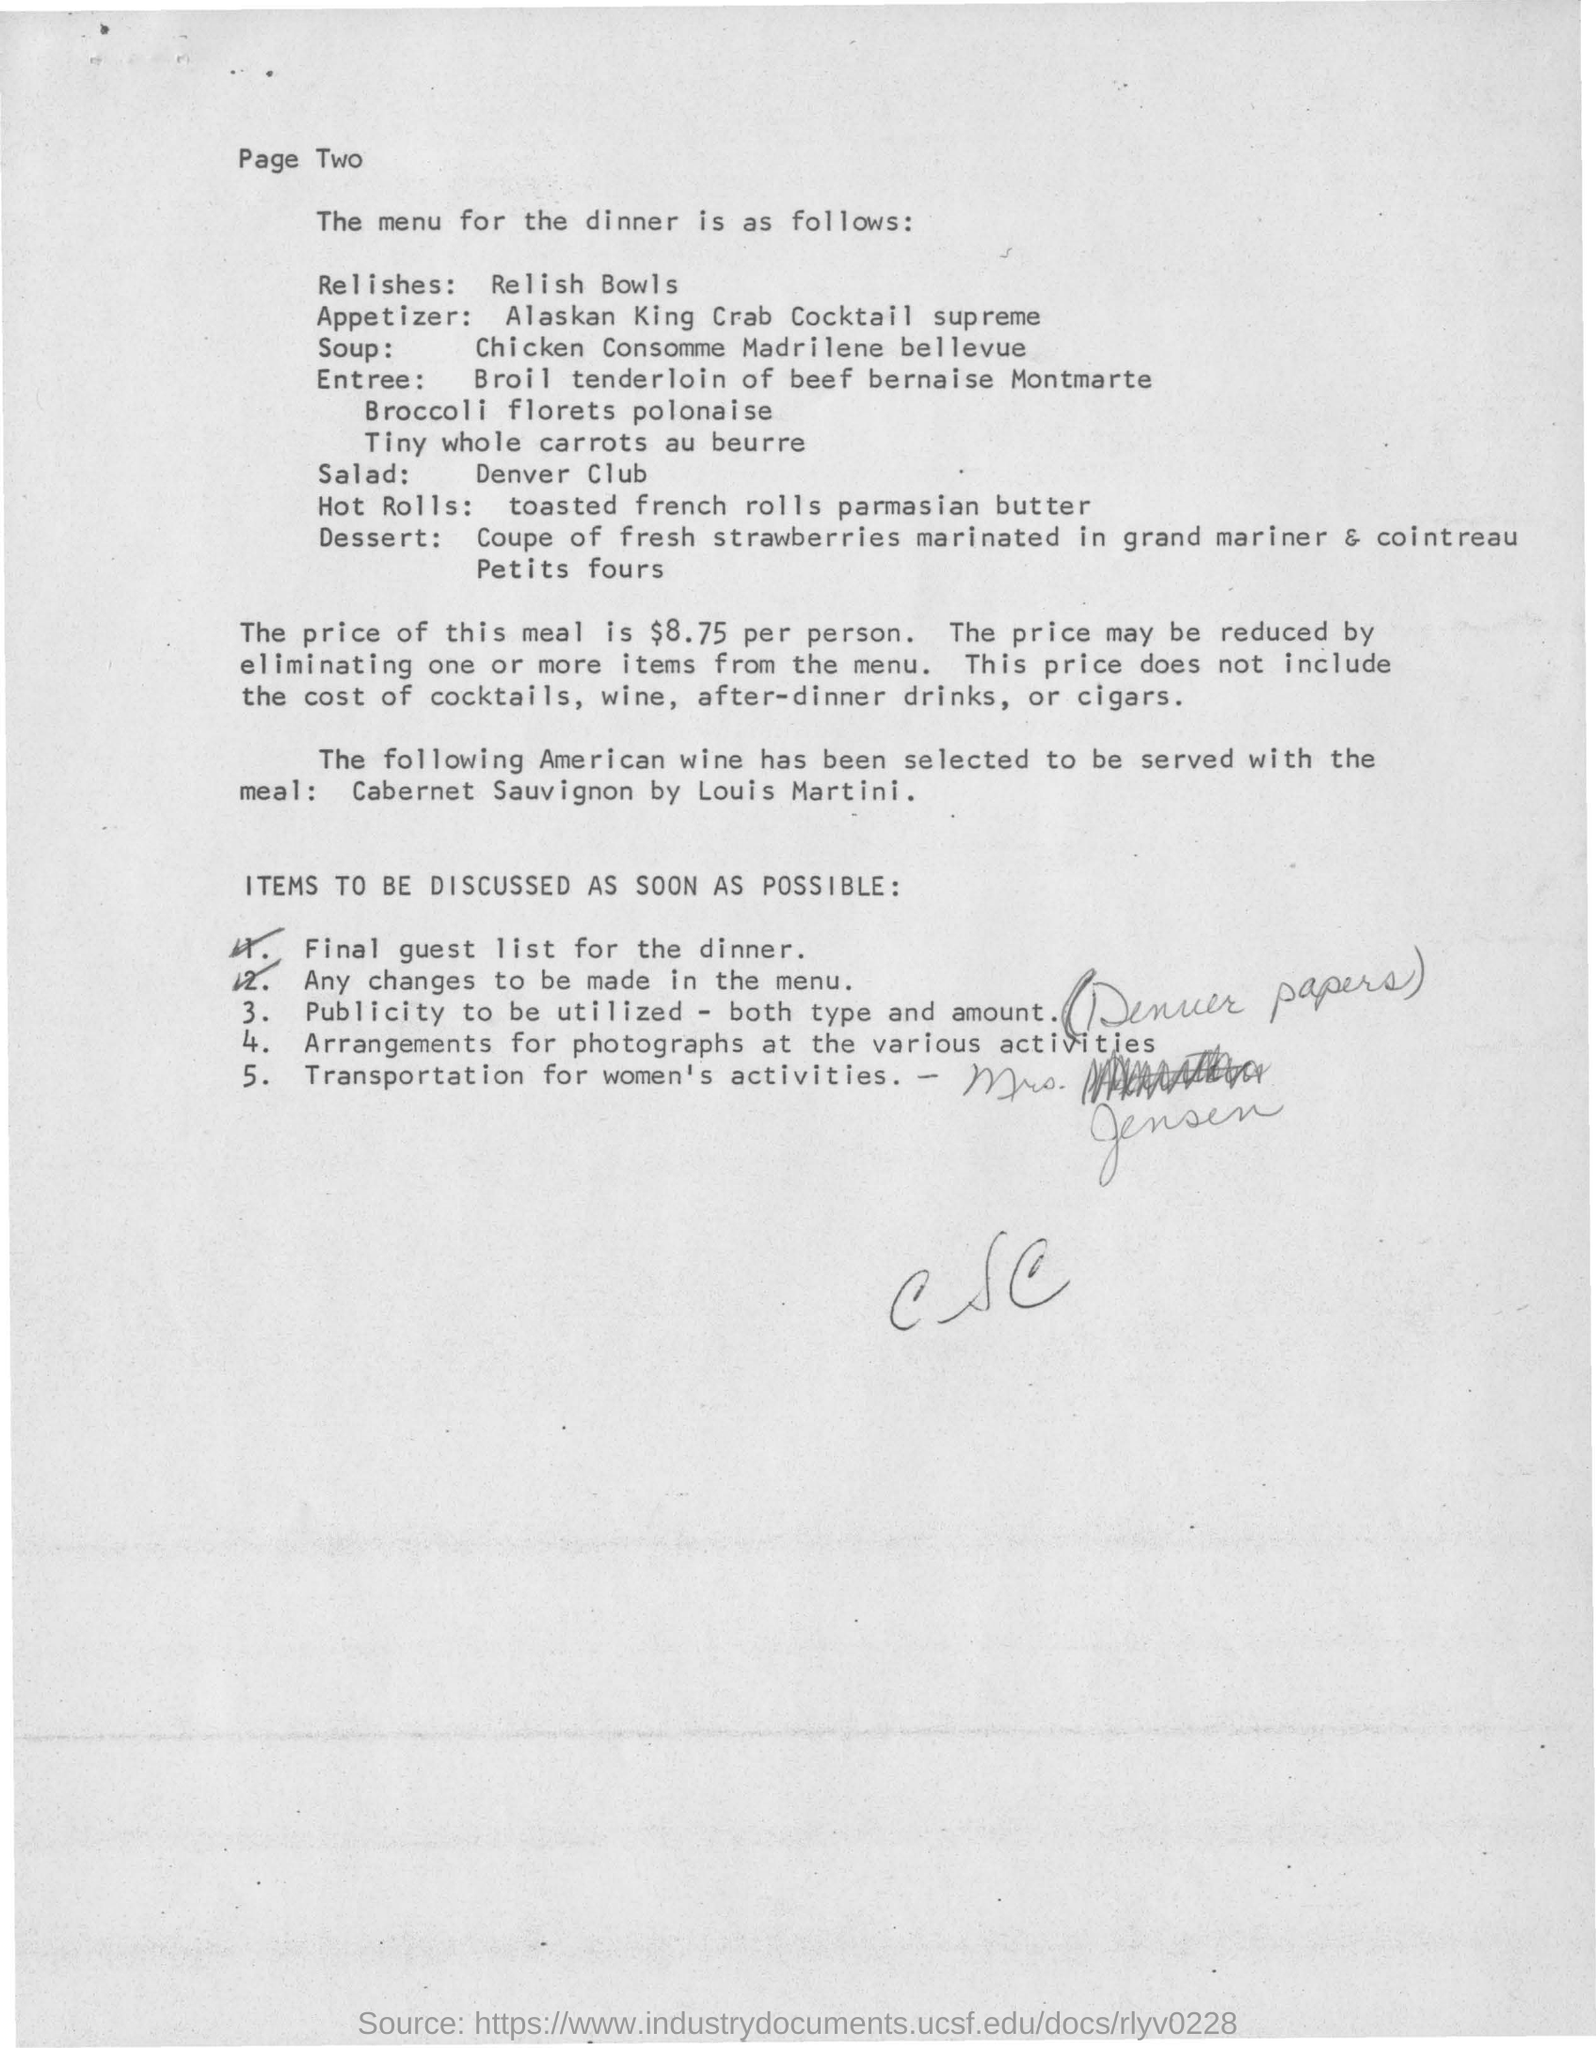What is the soup mentioned in menu for dinner?
Your response must be concise. Chicken consomme madrilene bellevue. What is the salad?
Give a very brief answer. Denver club. What kind of hot rolls followed as menu for dinner?
Your response must be concise. Toasted french rolls parmasian butter. What is the price of dinner menu meal per person?
Ensure brevity in your answer.  $8.75. What happens by eliminating one or more items from menu?
Provide a short and direct response. Price may be reduced. Which are not included cost in the price of meal ?
Ensure brevity in your answer.  Cost of cocktails, wine, after-dinner drinks, or cigars. Which american wine has been selected to serve with the meal?
Offer a very short reply. Cabernet sauvignon by Louis martini. What kind of dessert to be served for dinner as followed by menu?
Your response must be concise. Coupe of fresh strawberries marinated in grand mariner & cointreau Petits fours. 